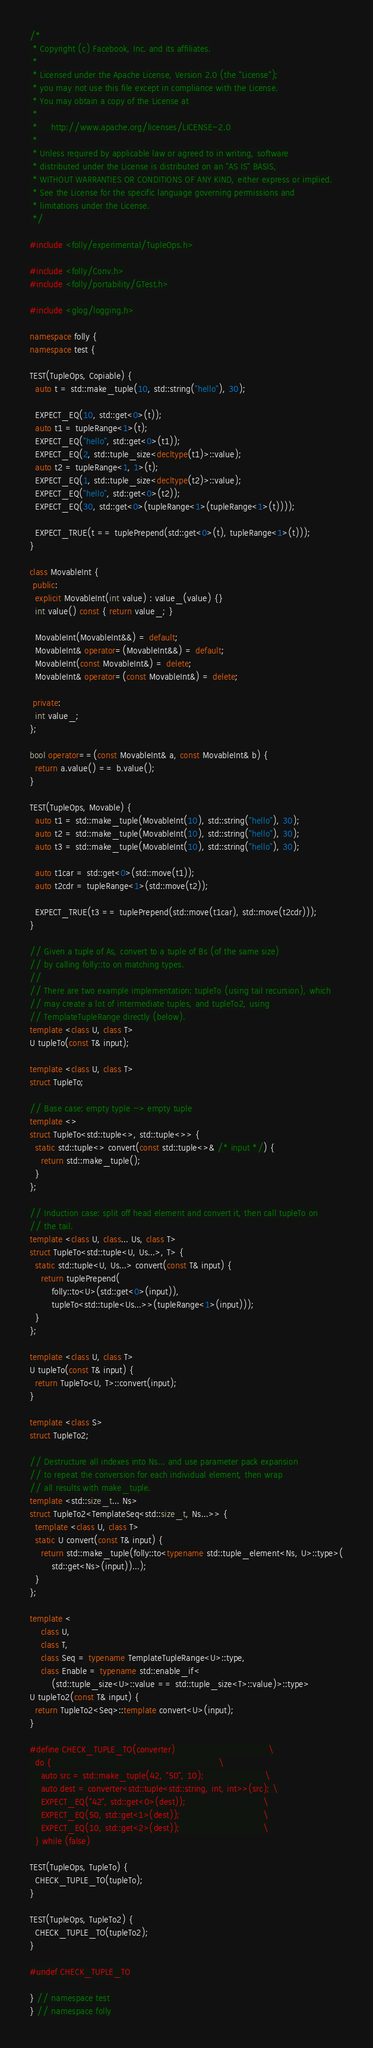Convert code to text. <code><loc_0><loc_0><loc_500><loc_500><_C++_>/*
 * Copyright (c) Facebook, Inc. and its affiliates.
 *
 * Licensed under the Apache License, Version 2.0 (the "License");
 * you may not use this file except in compliance with the License.
 * You may obtain a copy of the License at
 *
 *     http://www.apache.org/licenses/LICENSE-2.0
 *
 * Unless required by applicable law or agreed to in writing, software
 * distributed under the License is distributed on an "AS IS" BASIS,
 * WITHOUT WARRANTIES OR CONDITIONS OF ANY KIND, either express or implied.
 * See the License for the specific language governing permissions and
 * limitations under the License.
 */

#include <folly/experimental/TupleOps.h>

#include <folly/Conv.h>
#include <folly/portability/GTest.h>

#include <glog/logging.h>

namespace folly {
namespace test {

TEST(TupleOps, Copiable) {
  auto t = std::make_tuple(10, std::string("hello"), 30);

  EXPECT_EQ(10, std::get<0>(t));
  auto t1 = tupleRange<1>(t);
  EXPECT_EQ("hello", std::get<0>(t1));
  EXPECT_EQ(2, std::tuple_size<decltype(t1)>::value);
  auto t2 = tupleRange<1, 1>(t);
  EXPECT_EQ(1, std::tuple_size<decltype(t2)>::value);
  EXPECT_EQ("hello", std::get<0>(t2));
  EXPECT_EQ(30, std::get<0>(tupleRange<1>(tupleRange<1>(t))));

  EXPECT_TRUE(t == tuplePrepend(std::get<0>(t), tupleRange<1>(t)));
}

class MovableInt {
 public:
  explicit MovableInt(int value) : value_(value) {}
  int value() const { return value_; }

  MovableInt(MovableInt&&) = default;
  MovableInt& operator=(MovableInt&&) = default;
  MovableInt(const MovableInt&) = delete;
  MovableInt& operator=(const MovableInt&) = delete;

 private:
  int value_;
};

bool operator==(const MovableInt& a, const MovableInt& b) {
  return a.value() == b.value();
}

TEST(TupleOps, Movable) {
  auto t1 = std::make_tuple(MovableInt(10), std::string("hello"), 30);
  auto t2 = std::make_tuple(MovableInt(10), std::string("hello"), 30);
  auto t3 = std::make_tuple(MovableInt(10), std::string("hello"), 30);

  auto t1car = std::get<0>(std::move(t1));
  auto t2cdr = tupleRange<1>(std::move(t2));

  EXPECT_TRUE(t3 == tuplePrepend(std::move(t1car), std::move(t2cdr)));
}

// Given a tuple of As, convert to a tuple of Bs (of the same size)
// by calling folly::to on matching types.
//
// There are two example implementation: tupleTo (using tail recursion), which
// may create a lot of intermediate tuples, and tupleTo2, using
// TemplateTupleRange directly (below).
template <class U, class T>
U tupleTo(const T& input);

template <class U, class T>
struct TupleTo;

// Base case: empty typle -> empty tuple
template <>
struct TupleTo<std::tuple<>, std::tuple<>> {
  static std::tuple<> convert(const std::tuple<>& /* input */) {
    return std::make_tuple();
  }
};

// Induction case: split off head element and convert it, then call tupleTo on
// the tail.
template <class U, class... Us, class T>
struct TupleTo<std::tuple<U, Us...>, T> {
  static std::tuple<U, Us...> convert(const T& input) {
    return tuplePrepend(
        folly::to<U>(std::get<0>(input)),
        tupleTo<std::tuple<Us...>>(tupleRange<1>(input)));
  }
};

template <class U, class T>
U tupleTo(const T& input) {
  return TupleTo<U, T>::convert(input);
}

template <class S>
struct TupleTo2;

// Destructure all indexes into Ns... and use parameter pack expansion
// to repeat the conversion for each individual element, then wrap
// all results with make_tuple.
template <std::size_t... Ns>
struct TupleTo2<TemplateSeq<std::size_t, Ns...>> {
  template <class U, class T>
  static U convert(const T& input) {
    return std::make_tuple(folly::to<typename std::tuple_element<Ns, U>::type>(
        std::get<Ns>(input))...);
  }
};

template <
    class U,
    class T,
    class Seq = typename TemplateTupleRange<U>::type,
    class Enable = typename std::enable_if<
        (std::tuple_size<U>::value == std::tuple_size<T>::value)>::type>
U tupleTo2(const T& input) {
  return TupleTo2<Seq>::template convert<U>(input);
}

#define CHECK_TUPLE_TO(converter)                                  \
  do {                                                             \
    auto src = std::make_tuple(42, "50", 10);                      \
    auto dest = converter<std::tuple<std::string, int, int>>(src); \
    EXPECT_EQ("42", std::get<0>(dest));                            \
    EXPECT_EQ(50, std::get<1>(dest));                              \
    EXPECT_EQ(10, std::get<2>(dest));                              \
  } while (false)

TEST(TupleOps, TupleTo) {
  CHECK_TUPLE_TO(tupleTo);
}

TEST(TupleOps, TupleTo2) {
  CHECK_TUPLE_TO(tupleTo2);
}

#undef CHECK_TUPLE_TO

} // namespace test
} // namespace folly
</code> 